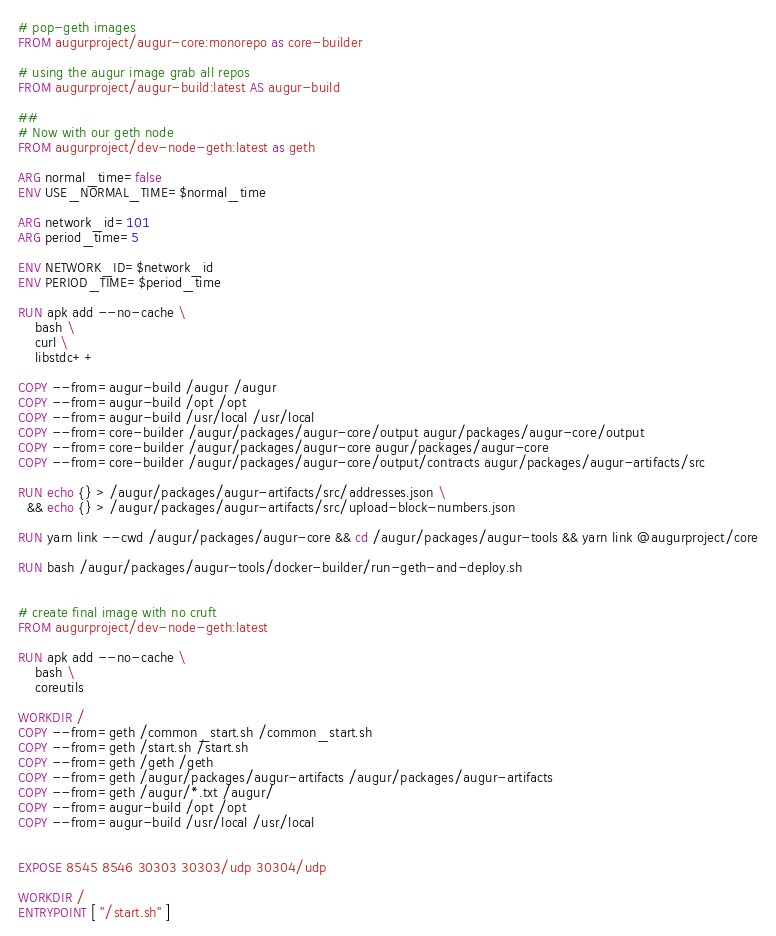Convert code to text. <code><loc_0><loc_0><loc_500><loc_500><_Dockerfile_># pop-geth images
FROM augurproject/augur-core:monorepo as core-builder

# using the augur image grab all repos
FROM augurproject/augur-build:latest AS augur-build

##
# Now with our geth node
FROM augurproject/dev-node-geth:latest as geth

ARG normal_time=false
ENV USE_NORMAL_TIME=$normal_time

ARG network_id=101
ARG period_time=5

ENV NETWORK_ID=$network_id
ENV PERIOD_TIME=$period_time

RUN apk add --no-cache \
    bash \
    curl \
    libstdc++

COPY --from=augur-build /augur /augur
COPY --from=augur-build /opt /opt
COPY --from=augur-build /usr/local /usr/local
COPY --from=core-builder /augur/packages/augur-core/output augur/packages/augur-core/output
COPY --from=core-builder /augur/packages/augur-core augur/packages/augur-core
COPY --from=core-builder /augur/packages/augur-core/output/contracts augur/packages/augur-artifacts/src

RUN echo {} > /augur/packages/augur-artifacts/src/addresses.json \
  && echo {} > /augur/packages/augur-artifacts/src/upload-block-numbers.json

RUN yarn link --cwd /augur/packages/augur-core && cd /augur/packages/augur-tools && yarn link @augurproject/core

RUN bash /augur/packages/augur-tools/docker-builder/run-geth-and-deploy.sh


# create final image with no cruft
FROM augurproject/dev-node-geth:latest

RUN apk add --no-cache \
    bash \
    coreutils

WORKDIR /
COPY --from=geth /common_start.sh /common_start.sh
COPY --from=geth /start.sh /start.sh
COPY --from=geth /geth /geth
COPY --from=geth /augur/packages/augur-artifacts /augur/packages/augur-artifacts
COPY --from=geth /augur/*.txt /augur/
COPY --from=augur-build /opt /opt
COPY --from=augur-build /usr/local /usr/local


EXPOSE 8545 8546 30303 30303/udp 30304/udp

WORKDIR /
ENTRYPOINT [ "/start.sh" ]
</code> 